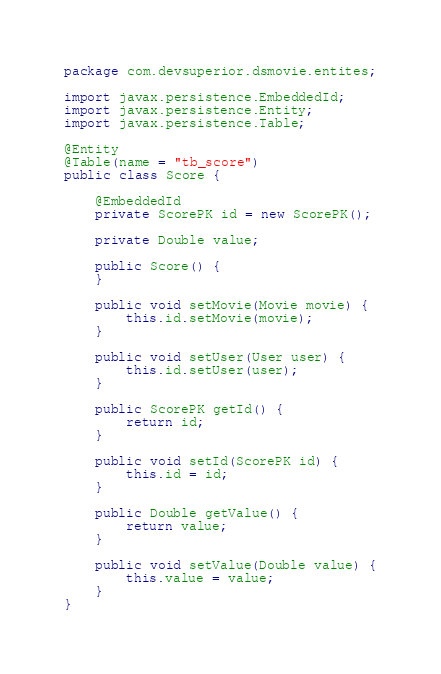<code> <loc_0><loc_0><loc_500><loc_500><_Java_>package com.devsuperior.dsmovie.entites;

import javax.persistence.EmbeddedId;
import javax.persistence.Entity;
import javax.persistence.Table;

@Entity
@Table(name = "tb_score")
public class Score {

	@EmbeddedId
	private ScorePK id = new ScorePK();
	
	private Double value;
	
	public Score() {
	}
	
	public void setMovie(Movie movie) {
		this.id.setMovie(movie);
	}
	
	public void setUser(User user) {
		this.id.setUser(user);
	}

	public ScorePK getId() {
		return id;
	}

	public void setId(ScorePK id) {
		this.id = id;
	}

	public Double getValue() {
		return value;
	}

	public void setValue(Double value) {
		this.value = value;
	}
}
</code> 